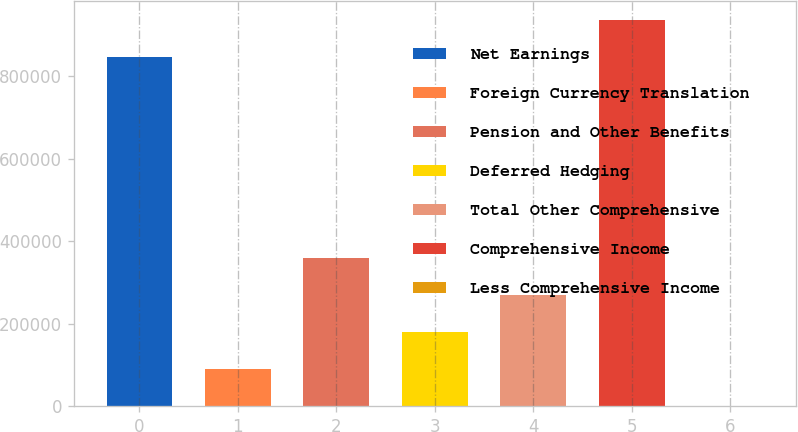Convert chart. <chart><loc_0><loc_0><loc_500><loc_500><bar_chart><fcel>Net Earnings<fcel>Foreign Currency Translation<fcel>Pension and Other Benefits<fcel>Deferred Hedging<fcel>Total Other Comprehensive<fcel>Comprehensive Income<fcel>Less Comprehensive Income<nl><fcel>847103<fcel>89886.3<fcel>358375<fcel>179383<fcel>268879<fcel>936599<fcel>390<nl></chart> 